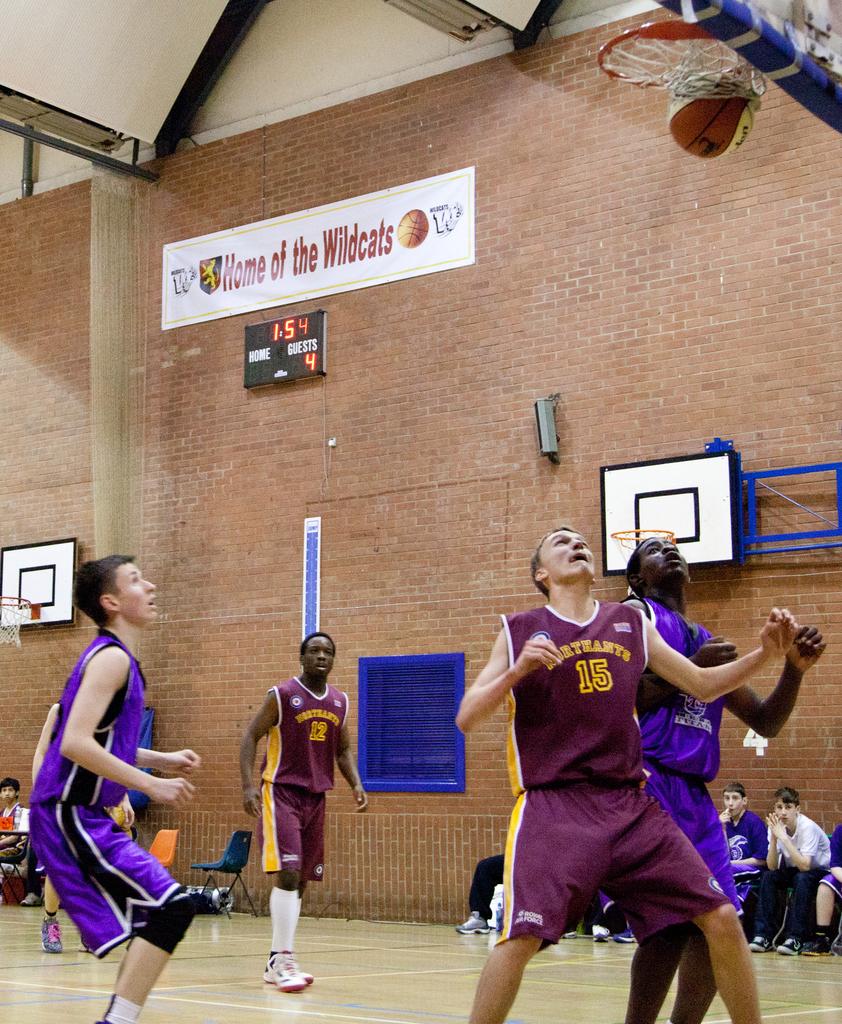What is this the home of?
Your answer should be compact. Wildcats. 